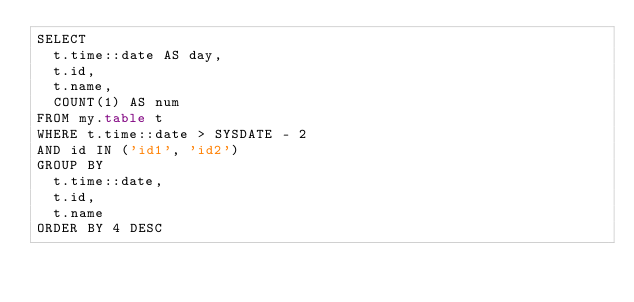<code> <loc_0><loc_0><loc_500><loc_500><_SQL_>SELECT
	t.time::date AS day,
	t.id,
	t.name,
	COUNT(1) AS num
FROM my.table t
WHERE t.time::date > SYSDATE - 2
AND id IN ('id1', 'id2')
GROUP BY
	t.time::date,
	t.id,
	t.name
ORDER BY 4 DESC
</code> 